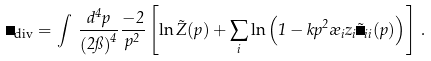Convert formula to latex. <formula><loc_0><loc_0><loc_500><loc_500>\Omega _ { \text {div} } = \int \, \frac { d ^ { 4 } p } { \left ( 2 \pi \right ) ^ { 4 } } \frac { - 2 } { p ^ { 2 } } \left [ \ln \tilde { Z } ( p ) + \sum _ { i } \ln \left ( 1 - k p ^ { 2 } \rho _ { i } z _ { i } \tilde { \Delta } _ { i i } ( p ) \right ) \right ] \, .</formula> 